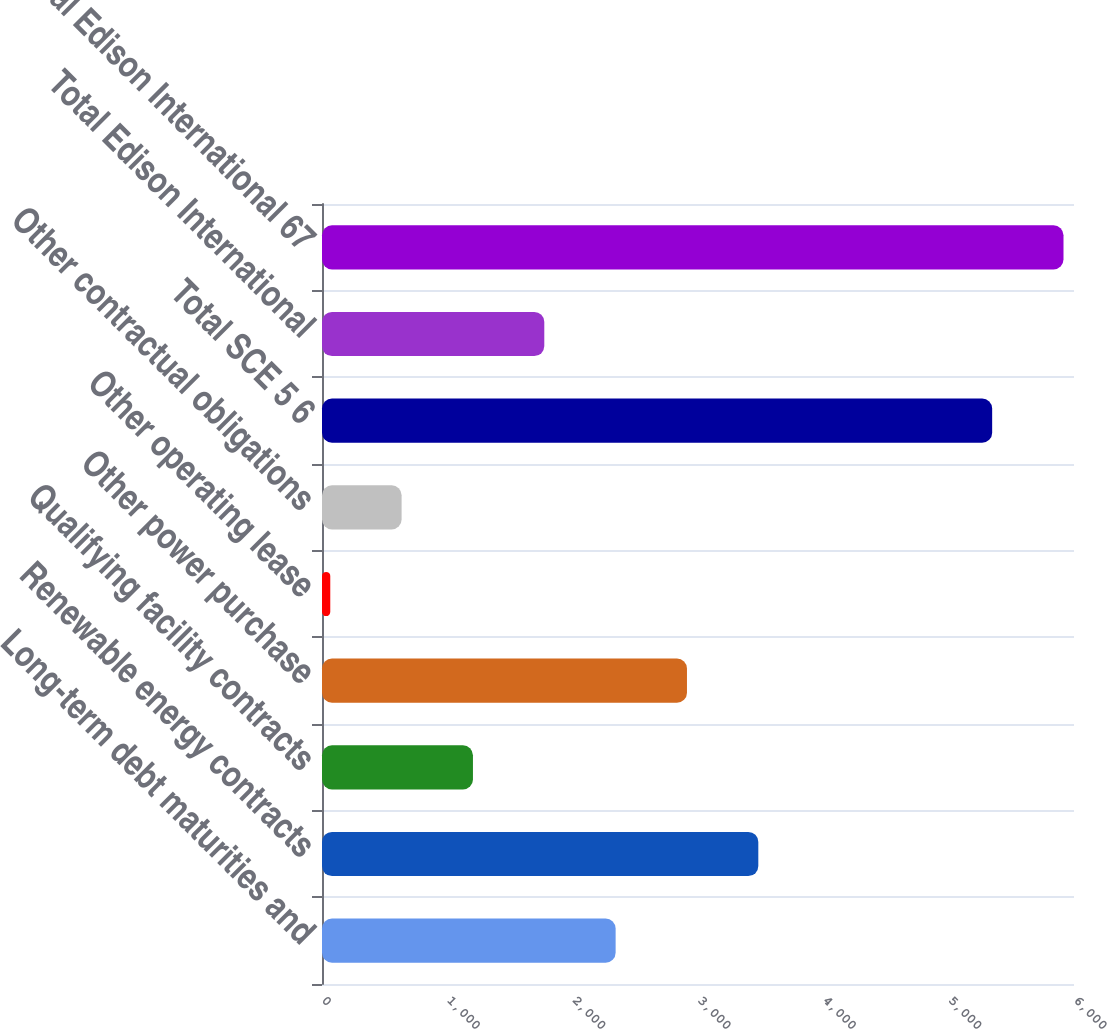Convert chart. <chart><loc_0><loc_0><loc_500><loc_500><bar_chart><fcel>Long-term debt maturities and<fcel>Renewable energy contracts<fcel>Qualifying facility contracts<fcel>Other power purchase<fcel>Other operating lease<fcel>Other contractual obligations<fcel>Total SCE 5 6<fcel>Total Edison International<fcel>Total Edison International 67<nl><fcel>2342.8<fcel>3481.2<fcel>1204.4<fcel>2912<fcel>66<fcel>635.2<fcel>5347<fcel>1773.6<fcel>5916.2<nl></chart> 